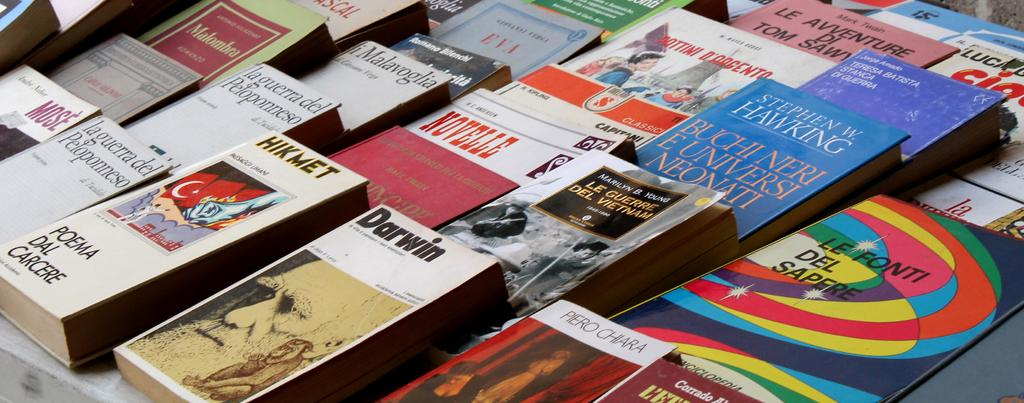Provide a one-sentence caption for the provided image. Books that are stacked beside each other about  Darwin and others. 